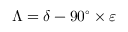Convert formula to latex. <formula><loc_0><loc_0><loc_500><loc_500>\Lambda = \delta - 9 0 ^ { \circ } \times \varepsilon</formula> 